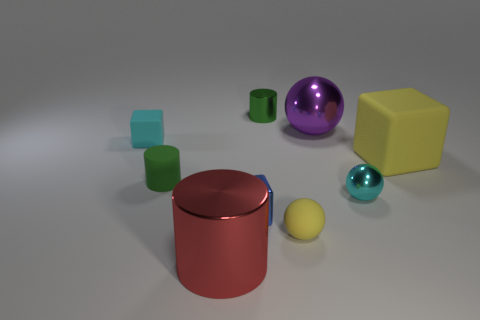Subtract all cyan cylinders. Subtract all cyan balls. How many cylinders are left? 3 Subtract all balls. How many objects are left? 6 Add 5 small rubber blocks. How many small rubber blocks exist? 6 Subtract 0 gray balls. How many objects are left? 9 Subtract all small cyan matte things. Subtract all red metallic objects. How many objects are left? 7 Add 5 large metal things. How many large metal things are left? 7 